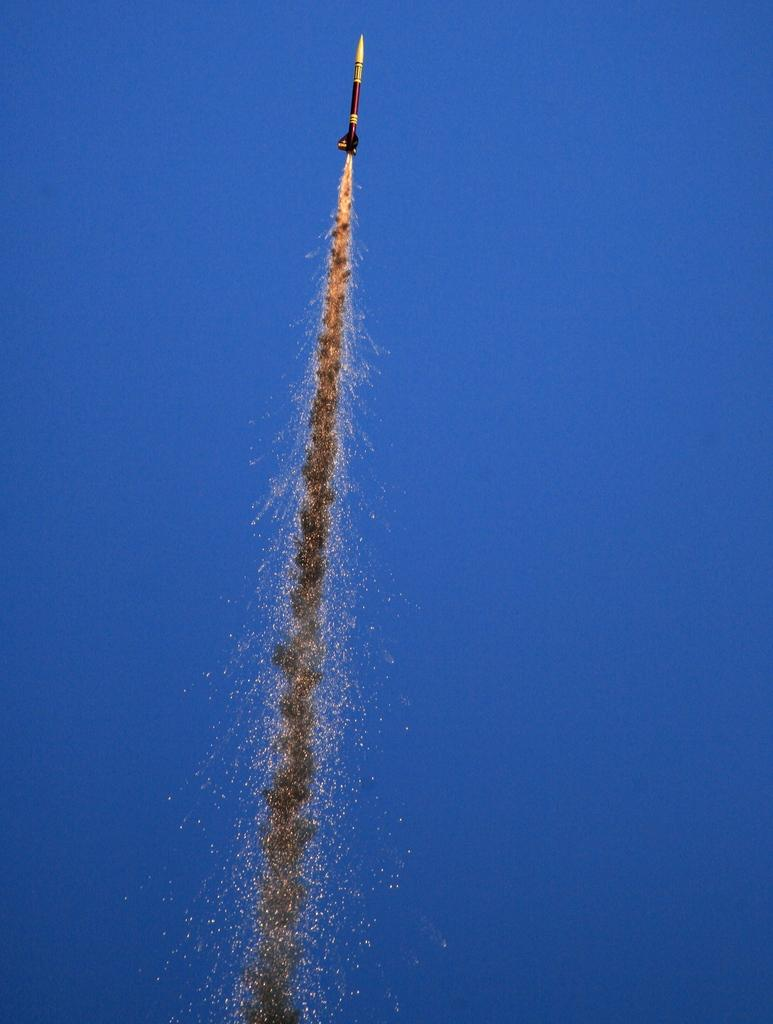What is the main subject of the image? There is a rocket in the image. What is happening to the rocket? The rocket has fire. What can be seen in the background of the image? The sky is visible in the background of the image. How many chickens are sitting on the wool in the image? There are no chickens or wool present in the image. What type of airport can be seen in the image? There is no airport present in the image; it features a rocket with fire and a sky background. 